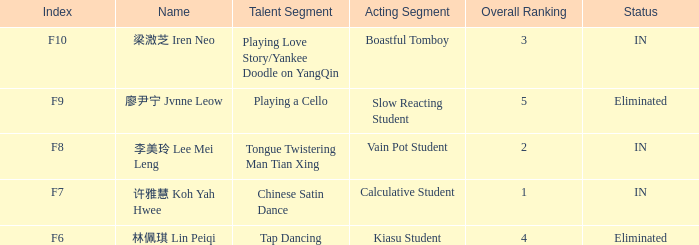What's the total number of overall rankings of 廖尹宁 jvnne leow's events that are eliminated? 1.0. Would you mind parsing the complete table? {'header': ['Index', 'Name', 'Talent Segment', 'Acting Segment', 'Overall Ranking', 'Status'], 'rows': [['F10', '梁溦芝 Iren Neo', 'Playing Love Story/Yankee Doodle on YangQin', 'Boastful Tomboy', '3', 'IN'], ['F9', '廖尹宁 Jvnne Leow', 'Playing a Cello', 'Slow Reacting Student', '5', 'Eliminated'], ['F8', '李美玲 Lee Mei Leng', 'Tongue Twistering Man Tian Xing', 'Vain Pot Student', '2', 'IN'], ['F7', '许雅慧 Koh Yah Hwee', 'Chinese Satin Dance', 'Calculative Student', '1', 'IN'], ['F6', '林佩琪 Lin Peiqi', 'Tap Dancing', 'Kiasu Student', '4', 'Eliminated']]} 